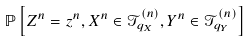<formula> <loc_0><loc_0><loc_500><loc_500>\mathbb { P } \left [ Z ^ { n } = z ^ { n } , X ^ { n } \in \mathcal { T } ^ { ( n ) } _ { q _ { X } } , Y ^ { n } \in \mathcal { T } ^ { ( n ) } _ { q _ { Y } } \right ]</formula> 